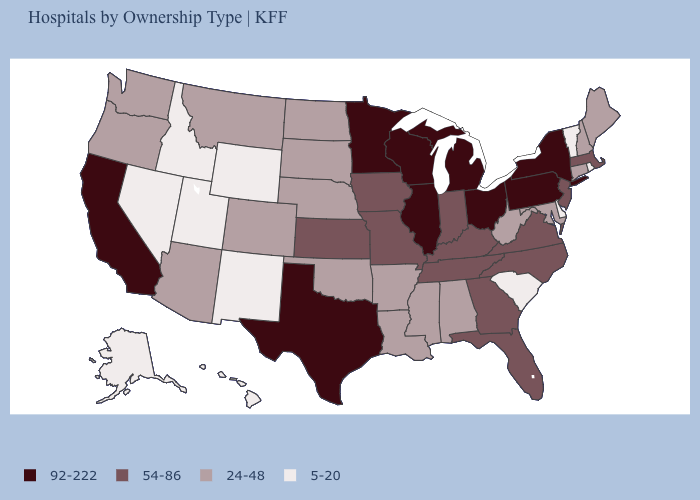What is the value of Tennessee?
Keep it brief. 54-86. Which states have the highest value in the USA?
Give a very brief answer. California, Illinois, Michigan, Minnesota, New York, Ohio, Pennsylvania, Texas, Wisconsin. What is the value of Rhode Island?
Quick response, please. 5-20. Which states hav the highest value in the MidWest?
Answer briefly. Illinois, Michigan, Minnesota, Ohio, Wisconsin. Does the first symbol in the legend represent the smallest category?
Give a very brief answer. No. What is the value of Wisconsin?
Quick response, please. 92-222. Name the states that have a value in the range 24-48?
Give a very brief answer. Alabama, Arizona, Arkansas, Colorado, Connecticut, Louisiana, Maine, Maryland, Mississippi, Montana, Nebraska, New Hampshire, North Dakota, Oklahoma, Oregon, South Dakota, Washington, West Virginia. Name the states that have a value in the range 54-86?
Short answer required. Florida, Georgia, Indiana, Iowa, Kansas, Kentucky, Massachusetts, Missouri, New Jersey, North Carolina, Tennessee, Virginia. Does Virginia have a higher value than Tennessee?
Answer briefly. No. Name the states that have a value in the range 92-222?
Be succinct. California, Illinois, Michigan, Minnesota, New York, Ohio, Pennsylvania, Texas, Wisconsin. How many symbols are there in the legend?
Be succinct. 4. What is the highest value in the USA?
Write a very short answer. 92-222. Among the states that border Missouri , which have the highest value?
Answer briefly. Illinois. What is the value of Delaware?
Concise answer only. 5-20. Which states have the lowest value in the USA?
Quick response, please. Alaska, Delaware, Hawaii, Idaho, Nevada, New Mexico, Rhode Island, South Carolina, Utah, Vermont, Wyoming. 